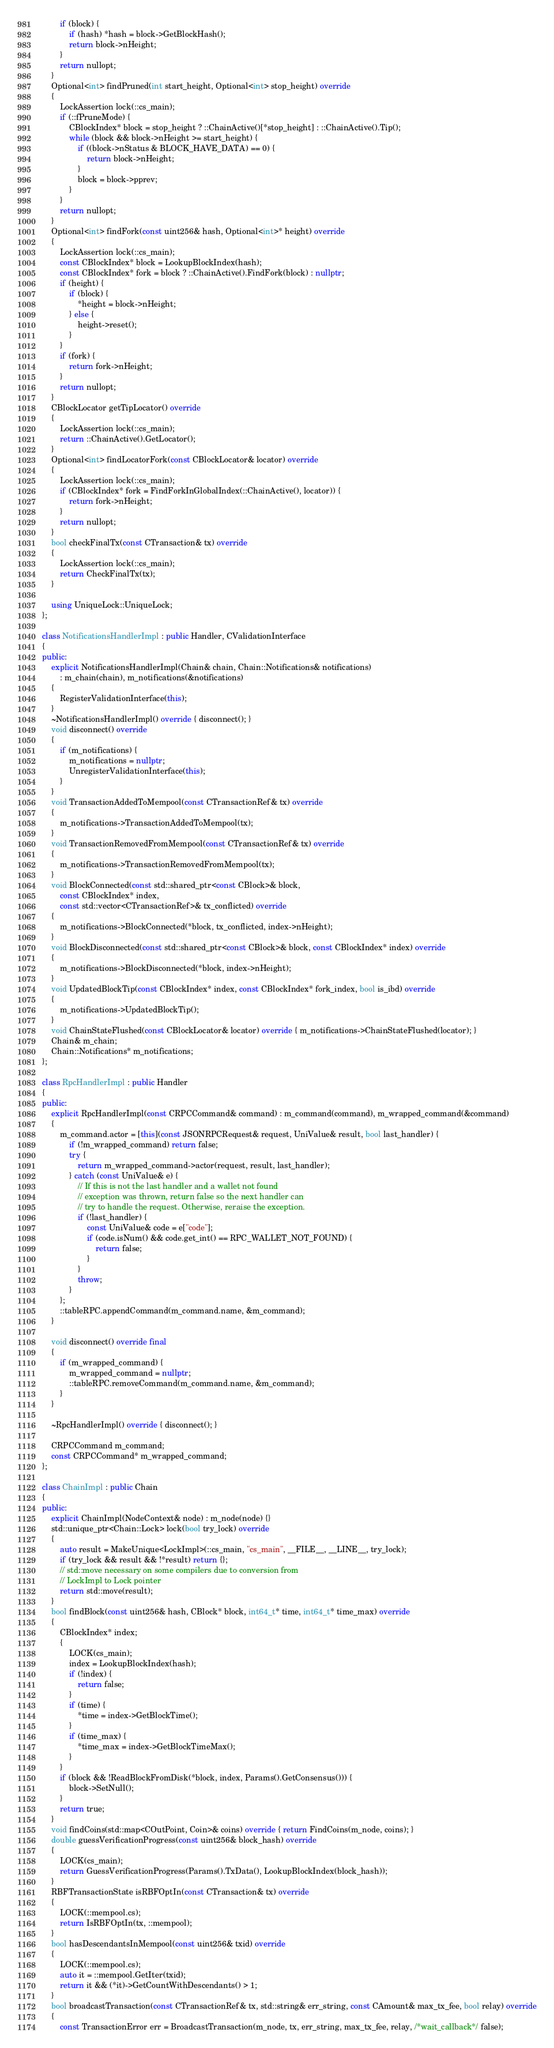Convert code to text. <code><loc_0><loc_0><loc_500><loc_500><_C++_>        if (block) {
            if (hash) *hash = block->GetBlockHash();
            return block->nHeight;
        }
        return nullopt;
    }
    Optional<int> findPruned(int start_height, Optional<int> stop_height) override
    {
        LockAssertion lock(::cs_main);
        if (::fPruneMode) {
            CBlockIndex* block = stop_height ? ::ChainActive()[*stop_height] : ::ChainActive().Tip();
            while (block && block->nHeight >= start_height) {
                if ((block->nStatus & BLOCK_HAVE_DATA) == 0) {
                    return block->nHeight;
                }
                block = block->pprev;
            }
        }
        return nullopt;
    }
    Optional<int> findFork(const uint256& hash, Optional<int>* height) override
    {
        LockAssertion lock(::cs_main);
        const CBlockIndex* block = LookupBlockIndex(hash);
        const CBlockIndex* fork = block ? ::ChainActive().FindFork(block) : nullptr;
        if (height) {
            if (block) {
                *height = block->nHeight;
            } else {
                height->reset();
            }
        }
        if (fork) {
            return fork->nHeight;
        }
        return nullopt;
    }
    CBlockLocator getTipLocator() override
    {
        LockAssertion lock(::cs_main);
        return ::ChainActive().GetLocator();
    }
    Optional<int> findLocatorFork(const CBlockLocator& locator) override
    {
        LockAssertion lock(::cs_main);
        if (CBlockIndex* fork = FindForkInGlobalIndex(::ChainActive(), locator)) {
            return fork->nHeight;
        }
        return nullopt;
    }
    bool checkFinalTx(const CTransaction& tx) override
    {
        LockAssertion lock(::cs_main);
        return CheckFinalTx(tx);
    }

    using UniqueLock::UniqueLock;
};

class NotificationsHandlerImpl : public Handler, CValidationInterface
{
public:
    explicit NotificationsHandlerImpl(Chain& chain, Chain::Notifications& notifications)
        : m_chain(chain), m_notifications(&notifications)
    {
        RegisterValidationInterface(this);
    }
    ~NotificationsHandlerImpl() override { disconnect(); }
    void disconnect() override
    {
        if (m_notifications) {
            m_notifications = nullptr;
            UnregisterValidationInterface(this);
        }
    }
    void TransactionAddedToMempool(const CTransactionRef& tx) override
    {
        m_notifications->TransactionAddedToMempool(tx);
    }
    void TransactionRemovedFromMempool(const CTransactionRef& tx) override
    {
        m_notifications->TransactionRemovedFromMempool(tx);
    }
    void BlockConnected(const std::shared_ptr<const CBlock>& block,
        const CBlockIndex* index,
        const std::vector<CTransactionRef>& tx_conflicted) override
    {
        m_notifications->BlockConnected(*block, tx_conflicted, index->nHeight);
    }
    void BlockDisconnected(const std::shared_ptr<const CBlock>& block, const CBlockIndex* index) override
    {
        m_notifications->BlockDisconnected(*block, index->nHeight);
    }
    void UpdatedBlockTip(const CBlockIndex* index, const CBlockIndex* fork_index, bool is_ibd) override
    {
        m_notifications->UpdatedBlockTip();
    }
    void ChainStateFlushed(const CBlockLocator& locator) override { m_notifications->ChainStateFlushed(locator); }
    Chain& m_chain;
    Chain::Notifications* m_notifications;
};

class RpcHandlerImpl : public Handler
{
public:
    explicit RpcHandlerImpl(const CRPCCommand& command) : m_command(command), m_wrapped_command(&command)
    {
        m_command.actor = [this](const JSONRPCRequest& request, UniValue& result, bool last_handler) {
            if (!m_wrapped_command) return false;
            try {
                return m_wrapped_command->actor(request, result, last_handler);
            } catch (const UniValue& e) {
                // If this is not the last handler and a wallet not found
                // exception was thrown, return false so the next handler can
                // try to handle the request. Otherwise, reraise the exception.
                if (!last_handler) {
                    const UniValue& code = e["code"];
                    if (code.isNum() && code.get_int() == RPC_WALLET_NOT_FOUND) {
                        return false;
                    }
                }
                throw;
            }
        };
        ::tableRPC.appendCommand(m_command.name, &m_command);
    }

    void disconnect() override final
    {
        if (m_wrapped_command) {
            m_wrapped_command = nullptr;
            ::tableRPC.removeCommand(m_command.name, &m_command);
        }
    }

    ~RpcHandlerImpl() override { disconnect(); }

    CRPCCommand m_command;
    const CRPCCommand* m_wrapped_command;
};

class ChainImpl : public Chain
{
public:
    explicit ChainImpl(NodeContext& node) : m_node(node) {}
    std::unique_ptr<Chain::Lock> lock(bool try_lock) override
    {
        auto result = MakeUnique<LockImpl>(::cs_main, "cs_main", __FILE__, __LINE__, try_lock);
        if (try_lock && result && !*result) return {};
        // std::move necessary on some compilers due to conversion from
        // LockImpl to Lock pointer
        return std::move(result);
    }
    bool findBlock(const uint256& hash, CBlock* block, int64_t* time, int64_t* time_max) override
    {
        CBlockIndex* index;
        {
            LOCK(cs_main);
            index = LookupBlockIndex(hash);
            if (!index) {
                return false;
            }
            if (time) {
                *time = index->GetBlockTime();
            }
            if (time_max) {
                *time_max = index->GetBlockTimeMax();
            }
        }
        if (block && !ReadBlockFromDisk(*block, index, Params().GetConsensus())) {
            block->SetNull();
        }
        return true;
    }
    void findCoins(std::map<COutPoint, Coin>& coins) override { return FindCoins(m_node, coins); }
    double guessVerificationProgress(const uint256& block_hash) override
    {
        LOCK(cs_main);
        return GuessVerificationProgress(Params().TxData(), LookupBlockIndex(block_hash));
    }
    RBFTransactionState isRBFOptIn(const CTransaction& tx) override
    {
        LOCK(::mempool.cs);
        return IsRBFOptIn(tx, ::mempool);
    }
    bool hasDescendantsInMempool(const uint256& txid) override
    {
        LOCK(::mempool.cs);
        auto it = ::mempool.GetIter(txid);
        return it && (*it)->GetCountWithDescendants() > 1;
    }
    bool broadcastTransaction(const CTransactionRef& tx, std::string& err_string, const CAmount& max_tx_fee, bool relay) override
    {
        const TransactionError err = BroadcastTransaction(m_node, tx, err_string, max_tx_fee, relay, /*wait_callback*/ false);</code> 